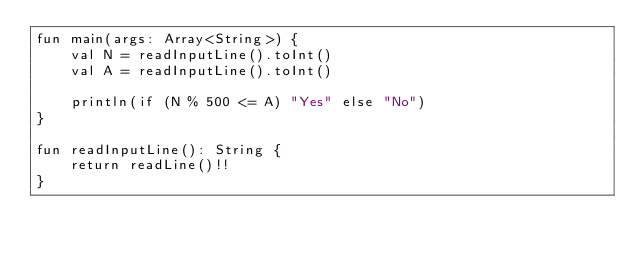Convert code to text. <code><loc_0><loc_0><loc_500><loc_500><_Kotlin_>fun main(args: Array<String>) {
    val N = readInputLine().toInt()
    val A = readInputLine().toInt()
    
    println(if (N % 500 <= A) "Yes" else "No")
}

fun readInputLine(): String {
    return readLine()!!
}
</code> 